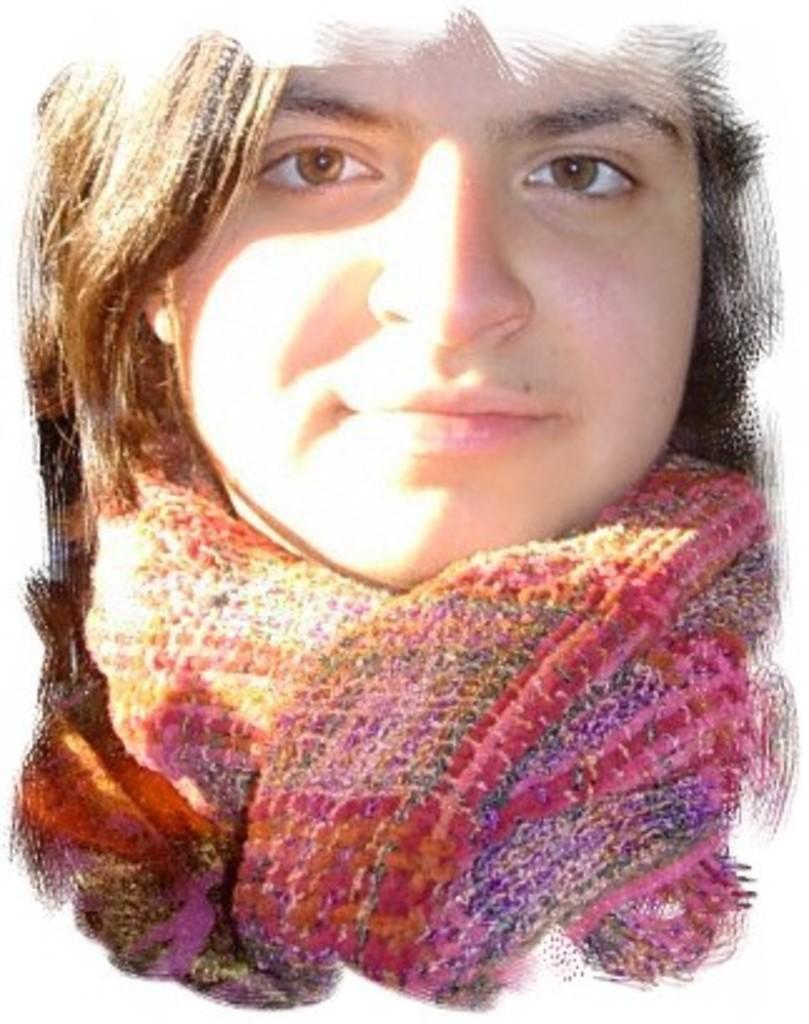What can be observed about the image itself? The image is edited. Who or what is present in the image? There is a person in the image. What is the person wearing around their neck? The person is wearing a neck scarf. What type of toothbrush is the person holding in the image? There is no toothbrush present in the image. Is the person playing a guitar in the image? There is no guitar present in the image. 